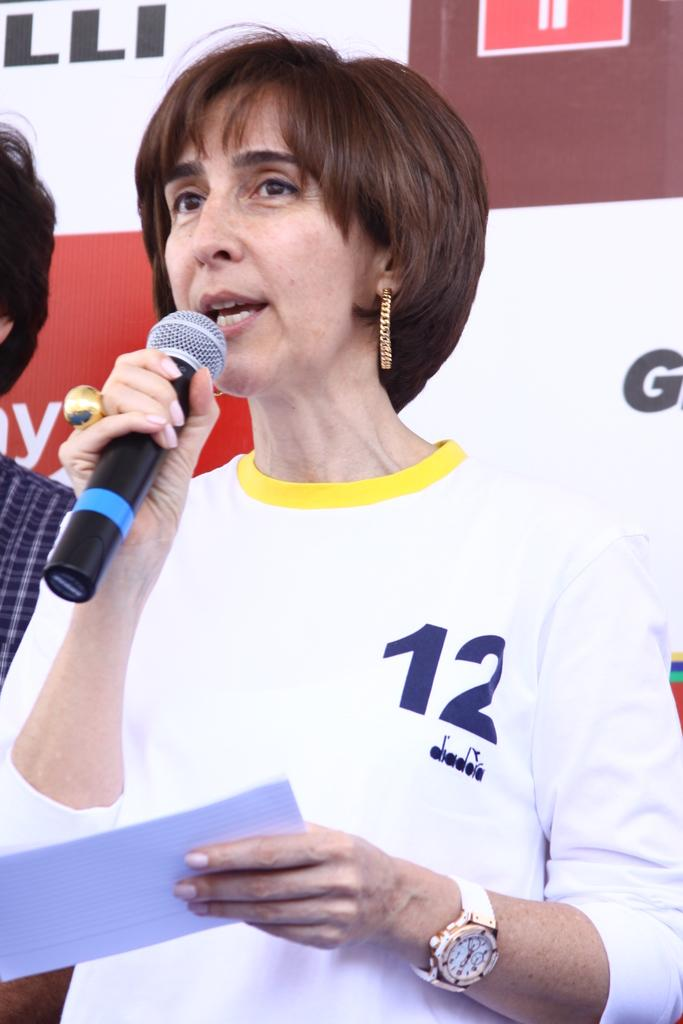What is the woman in the image wearing? The woman is wearing a t-shirt and a watch. What is the woman holding in the image? The woman is holding a mic and a paper. Can you describe the man in the image? The man is wearing a shirt. What is visible in the background of the image? There is a banner in the background of the image. What color is the paint on the wall in the image? There is no mention of paint or a wall in the image, so we cannot determine the color of any paint. 